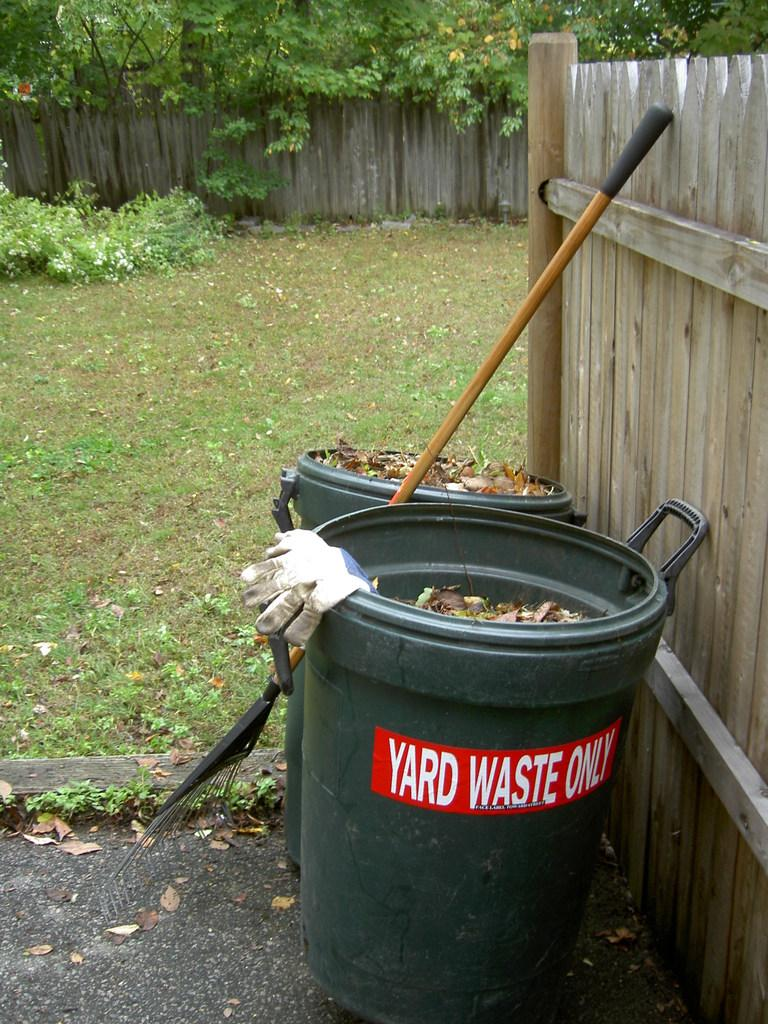<image>
Give a short and clear explanation of the subsequent image. A backyard with a rake and two trash cans next to a fence, one of which says "yard waste only" on it. 